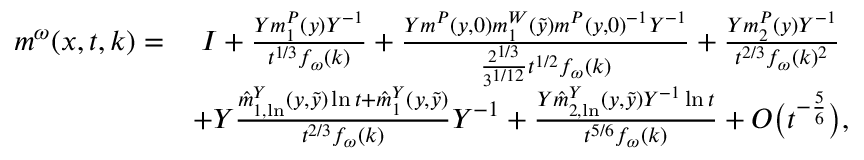<formula> <loc_0><loc_0><loc_500><loc_500>\begin{array} { r l } { m ^ { \omega } ( x , t , k ) = } & { \, I + \frac { Y m _ { 1 } ^ { P } ( y ) Y ^ { - 1 } } { t ^ { 1 / 3 } f _ { \omega } ( k ) } + \frac { Y m ^ { P } ( y , 0 ) m _ { 1 } ^ { W } ( \tilde { y } ) m ^ { P } ( y , 0 ) ^ { - 1 } Y ^ { - 1 } } { \frac { 2 ^ { 1 / 3 } } { 3 ^ { 1 / 1 2 } } t ^ { 1 / 2 } f _ { \omega } ( k ) } + \frac { Y m _ { 2 } ^ { P } ( y ) Y ^ { - 1 } } { t ^ { 2 / 3 } f _ { \omega } ( k ) ^ { 2 } } } \\ & { + Y \frac { \hat { m } _ { 1 , \ln } ^ { Y } ( y , \tilde { y } ) \ln t + \hat { m } _ { 1 } ^ { Y } ( y , \tilde { y } ) } { t ^ { 2 / 3 } f _ { \omega } ( k ) } Y ^ { - 1 } + \frac { Y \hat { m } _ { 2 , \ln } ^ { Y } ( y , \tilde { y } ) Y ^ { - 1 } \ln t } { t ^ { 5 / 6 } f _ { \omega } ( k ) } + O \left ( t ^ { - \frac { 5 } { 6 } } \right ) , } \end{array}</formula> 